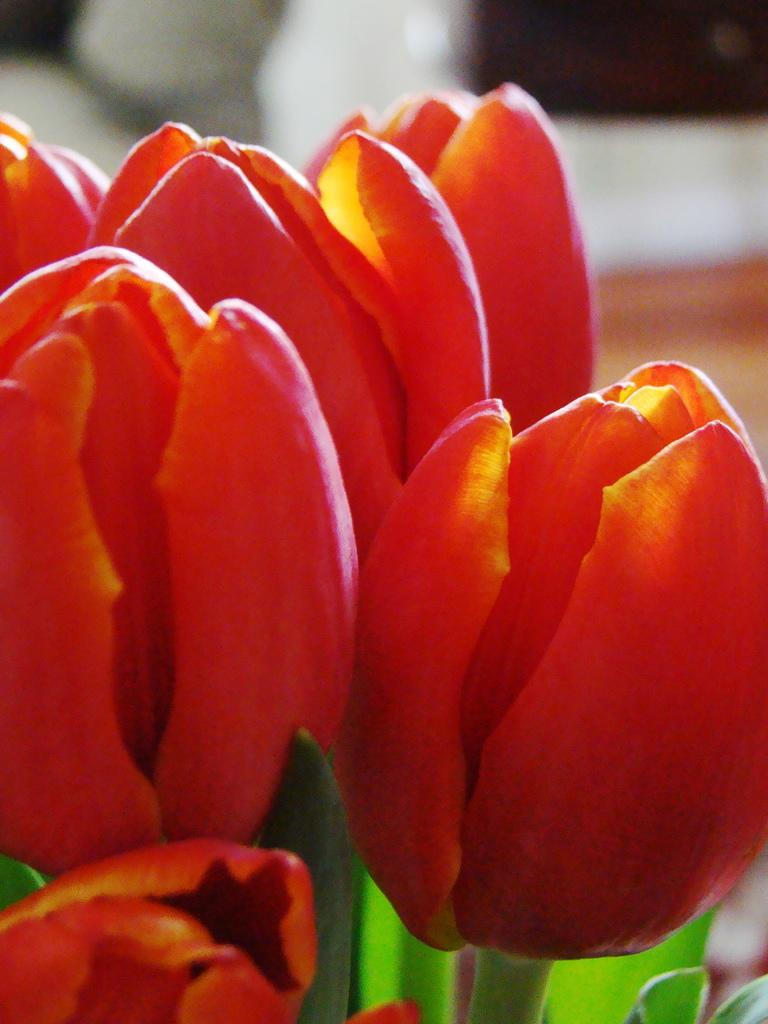What type of flora is present in the image? There are beautiful flowers in the image. Can you describe the background of the flowers? The background of the flowers is blurred. What type of lamp is being used to sing a song in the image? There is no lamp or singing in the image; it only features beautiful flowers with a blurred background. 